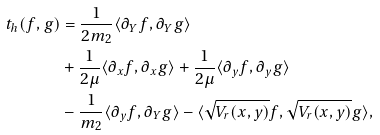Convert formula to latex. <formula><loc_0><loc_0><loc_500><loc_500>t _ { h } ( f , g ) & = \frac { 1 } { 2 m _ { 2 } } \langle \partial _ { Y } f , \partial _ { Y } g \rangle \\ & + \frac { 1 } { 2 \mu } \langle \partial _ { x } f , \partial _ { x } g \rangle + \frac { 1 } { 2 \mu } \langle \partial _ { y } f , \partial _ { y } g \rangle \\ & - \frac { 1 } { m _ { 2 } } \langle \partial _ { y } f , \partial _ { Y } g \rangle - \langle \sqrt { V _ { r } ( x , y ) } f , \sqrt { V _ { r } ( x , y ) } g \rangle ,</formula> 